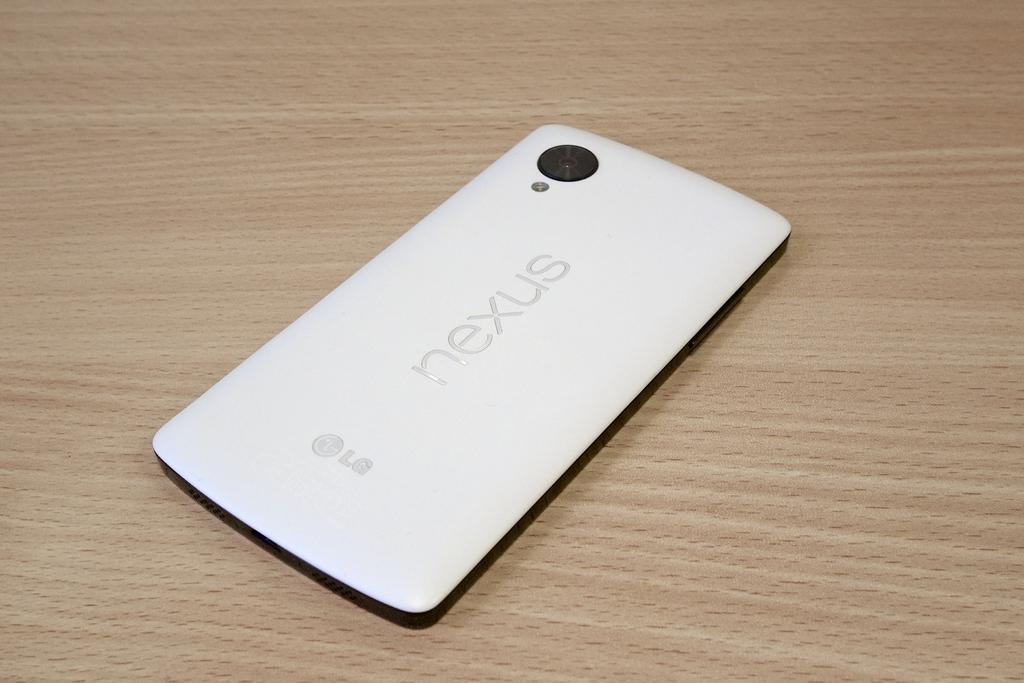<image>
Create a compact narrative representing the image presented. LG Nexus white cellphone laying face down on table 